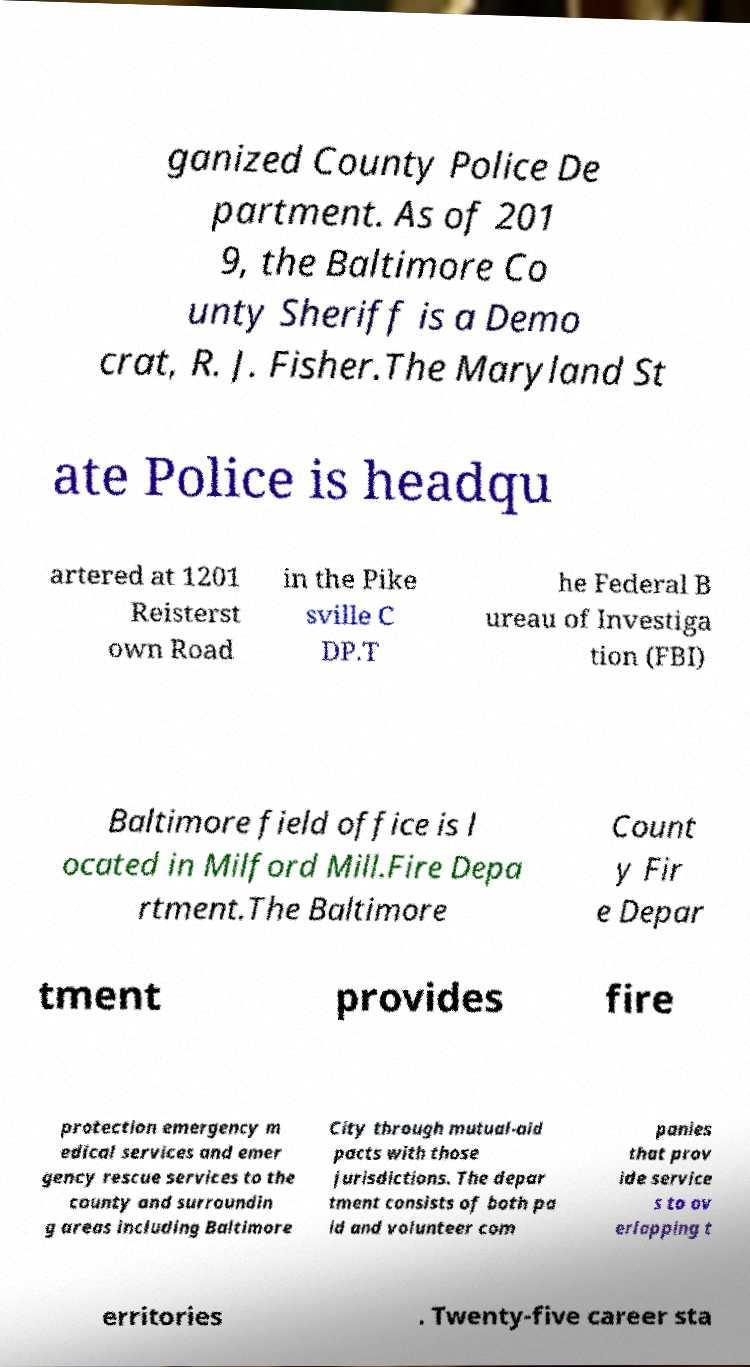What messages or text are displayed in this image? I need them in a readable, typed format. ganized County Police De partment. As of 201 9, the Baltimore Co unty Sheriff is a Demo crat, R. J. Fisher.The Maryland St ate Police is headqu artered at 1201 Reisterst own Road in the Pike sville C DP.T he Federal B ureau of Investiga tion (FBI) Baltimore field office is l ocated in Milford Mill.Fire Depa rtment.The Baltimore Count y Fir e Depar tment provides fire protection emergency m edical services and emer gency rescue services to the county and surroundin g areas including Baltimore City through mutual-aid pacts with those jurisdictions. The depar tment consists of both pa id and volunteer com panies that prov ide service s to ov erlapping t erritories . Twenty-five career sta 